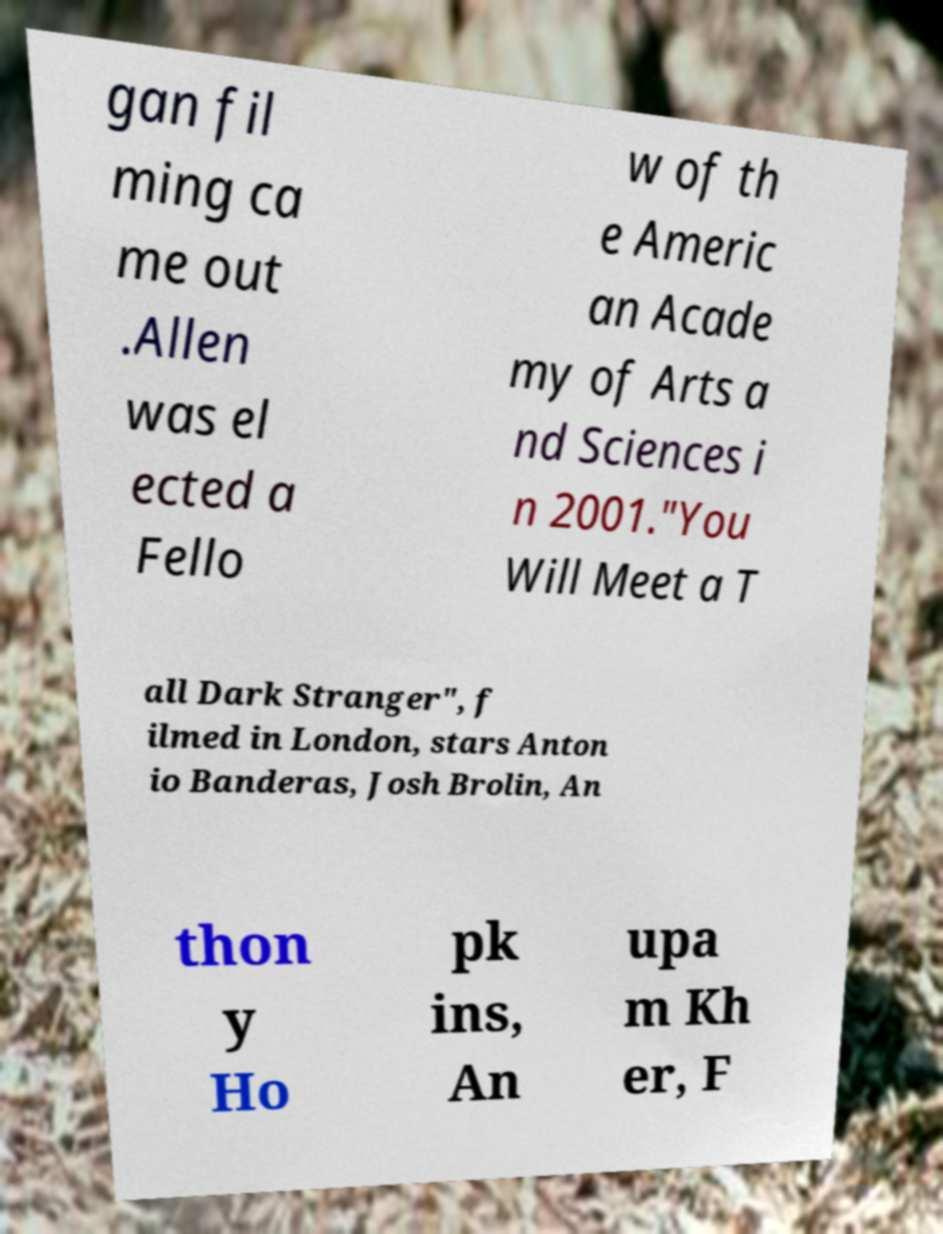Please identify and transcribe the text found in this image. gan fil ming ca me out .Allen was el ected a Fello w of th e Americ an Acade my of Arts a nd Sciences i n 2001."You Will Meet a T all Dark Stranger", f ilmed in London, stars Anton io Banderas, Josh Brolin, An thon y Ho pk ins, An upa m Kh er, F 